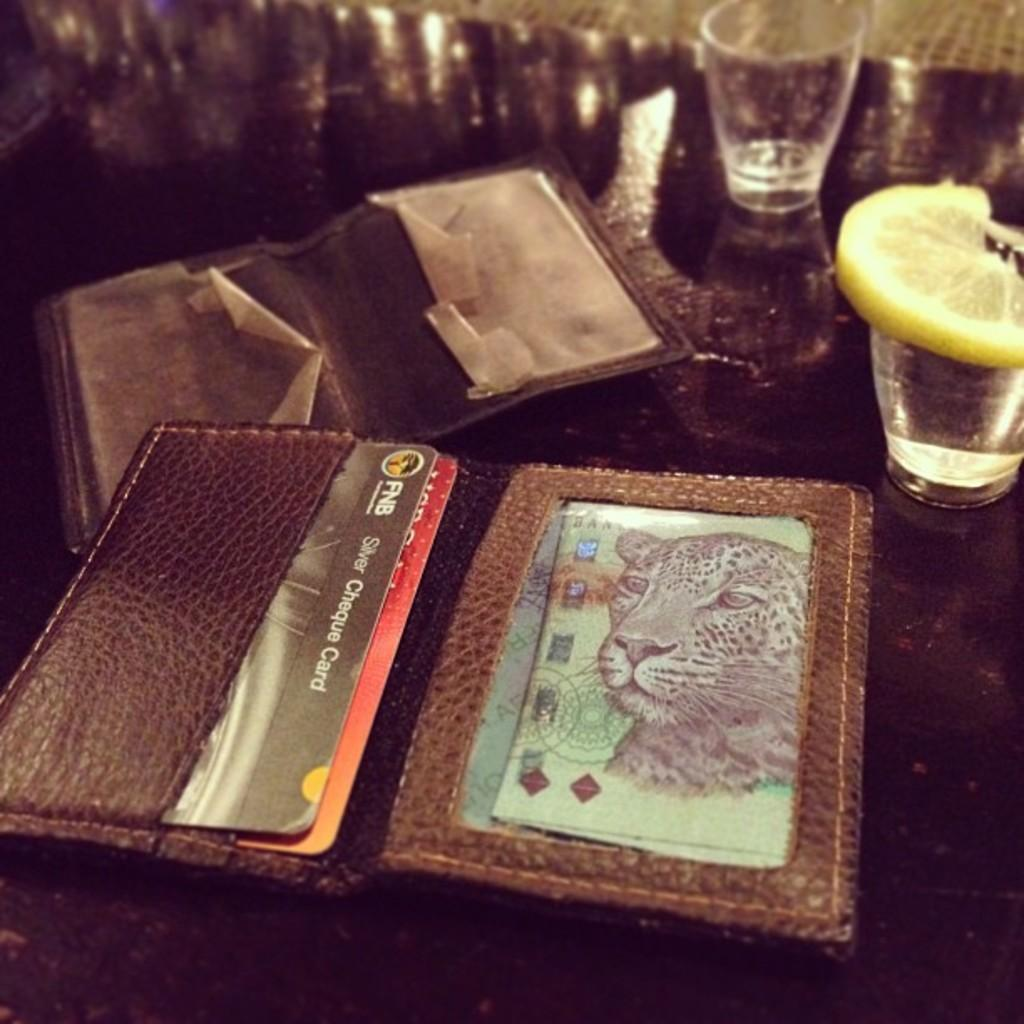<image>
Relay a brief, clear account of the picture shown. An open wallet shows a picture of a cheetah and an FNB credit card 